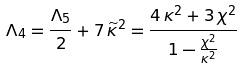<formula> <loc_0><loc_0><loc_500><loc_500>\Lambda _ { 4 } = \frac { \Lambda _ { 5 } } { 2 } + 7 \, \widetilde { \kappa } ^ { 2 } = \frac { 4 \, \kappa ^ { 2 } + 3 \, \chi ^ { 2 } } { 1 - \frac { \chi ^ { 2 } } { \kappa ^ { 2 } } }</formula> 